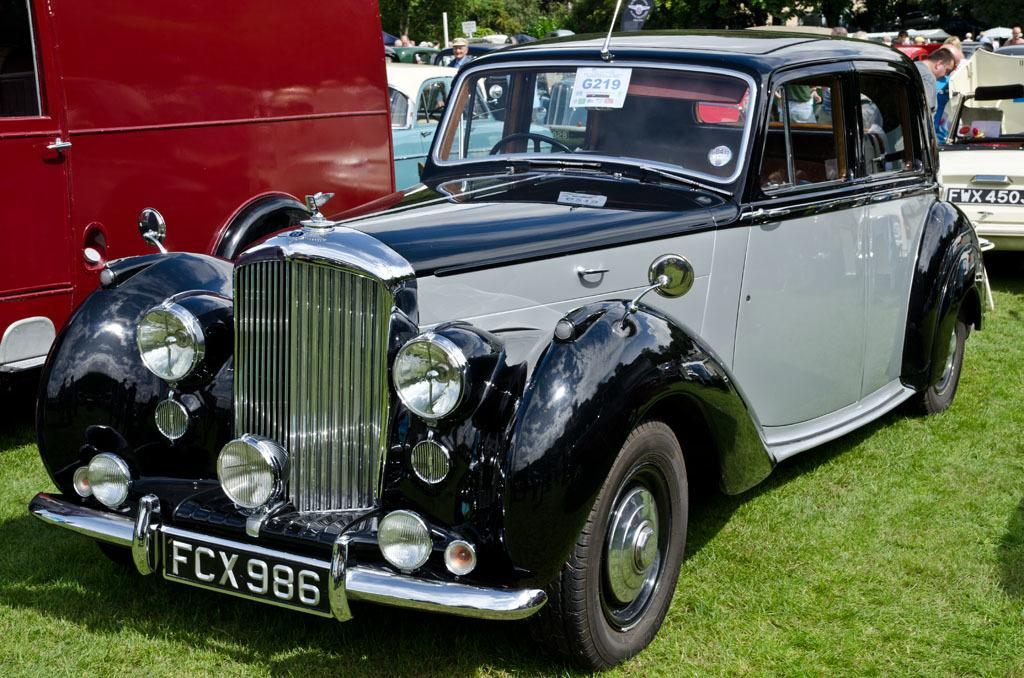Where is the car located in the image? The car is parked on the grass in the image. What else can be seen in the background of the image? There are vehicles, people, objects, and trees in the background of the image. What type of zinc can be seen in the image? There is no zinc present in the image. How many birds are visible in the image? There are no birds visible in the image. 